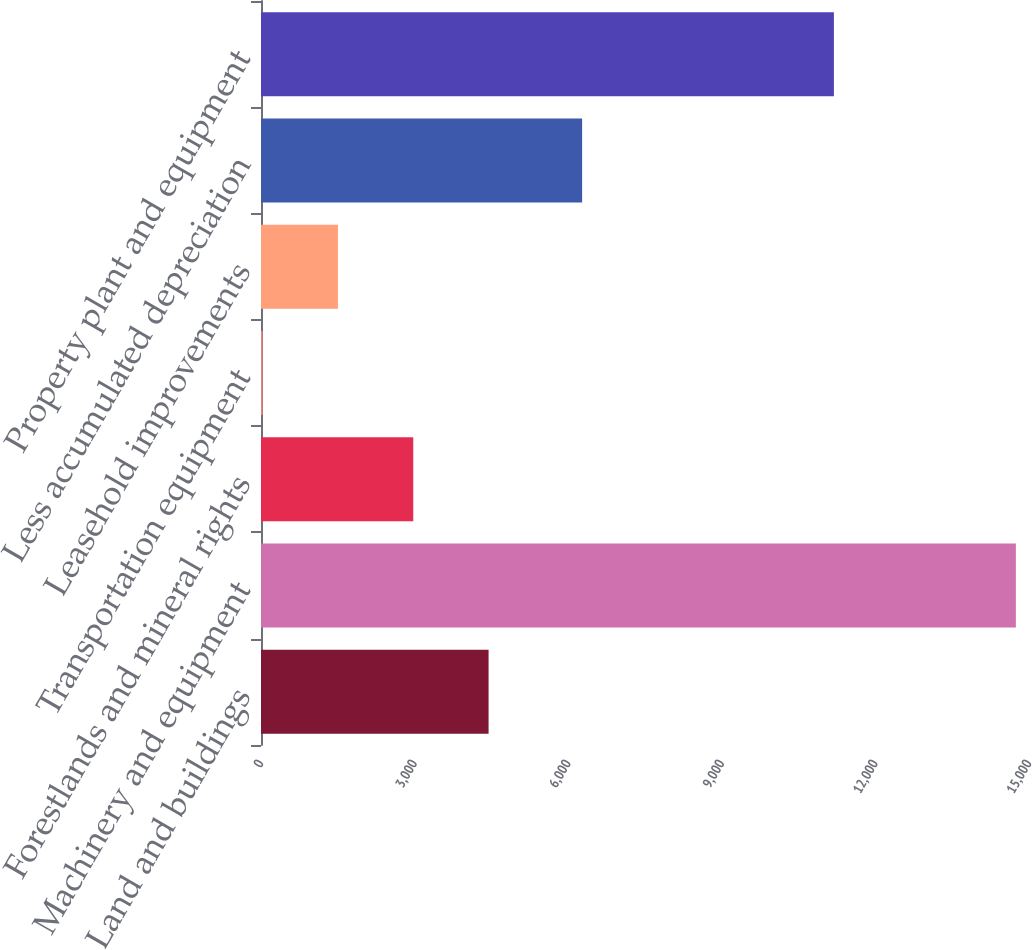Convert chart to OTSL. <chart><loc_0><loc_0><loc_500><loc_500><bar_chart><fcel>Land and buildings<fcel>Machinery and equipment<fcel>Forestlands and mineral rights<fcel>Transportation equipment<fcel>Leasehold improvements<fcel>Less accumulated depreciation<fcel>Property plant and equipment<nl><fcel>4444.92<fcel>14743.6<fcel>2973.68<fcel>31.2<fcel>1502.44<fcel>6271.8<fcel>11189.5<nl></chart> 